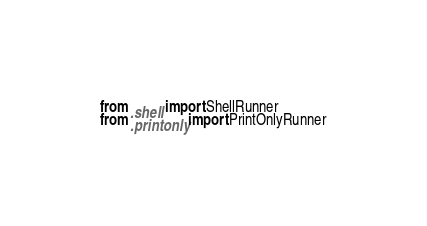<code> <loc_0><loc_0><loc_500><loc_500><_Python_>from .shell import ShellRunner
from .printonly import PrintOnlyRunner
</code> 